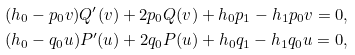<formula> <loc_0><loc_0><loc_500><loc_500>& ( h _ { 0 } - p _ { 0 } v ) Q ^ { \prime } ( v ) + 2 p _ { 0 } Q ( v ) + h _ { 0 } p _ { 1 } - h _ { 1 } p _ { 0 } v = 0 , \\ & ( h _ { 0 } - q _ { 0 } u ) P ^ { \prime } ( u ) + 2 q _ { 0 } P ( u ) + h _ { 0 } q _ { 1 } - h _ { 1 } q _ { 0 } u = 0 ,</formula> 